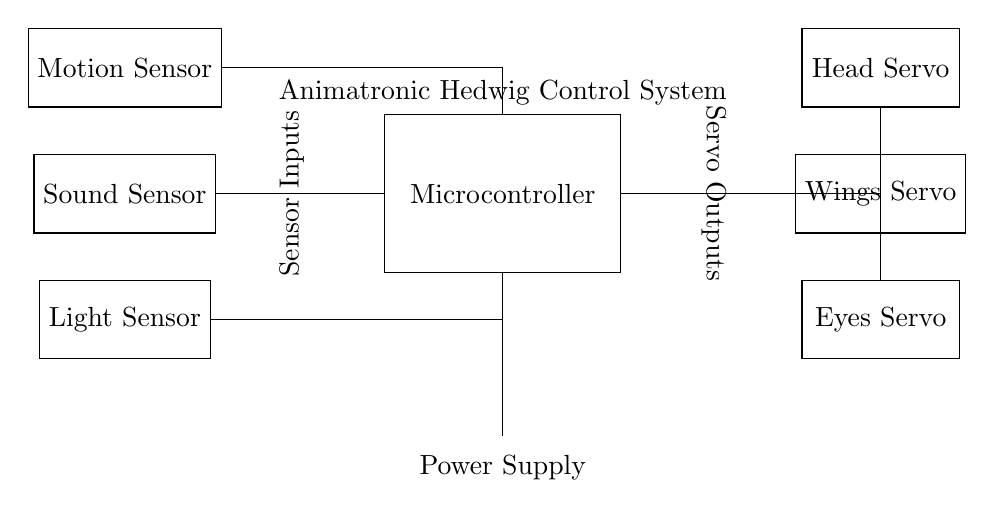What is the main component of the control system? The main component of the control system is the Microcontroller, which serves as the central unit to process sensor inputs and control servo outputs.
Answer: Microcontroller How many servo motors are in the circuit? The circuit features three servo motors: Head Servo, Wings Servo, and Eyes Servo. Each motor corresponds to different movements of the animatronic Hedwig.
Answer: Three What type of sensors are used in the circuit? The circuit uses three types of sensors: Motion Sensor, Sound Sensor, and Light Sensor, each designed to detect specific environmental inputs to interact with the animatronic.
Answer: Motion, Sound, Light Which component receives inputs from the sensors? The Microcontroller is the component that receives inputs from all three sensors, integrating the information to control the servos accordingly.
Answer: Microcontroller How does the Microcontroller connect to the Head Servo? The Microcontroller connects to the Head Servo using a direct connection indicated in the circuit, which allows it to send control signals directly for the movement.
Answer: Direct connection What is the function of the power supply in the circuit? The power supply provides the necessary voltage and current required to operate all the components of the circuit, ensuring they function correctly.
Answer: Power supply function What is the layout of the circuit in terms of inputs and outputs? The layout places sensors on the left side as inputs and servo motors on the right side as outputs, showing a clear separation between receiving signals and executing movements.
Answer: Inputs left, outputs right 